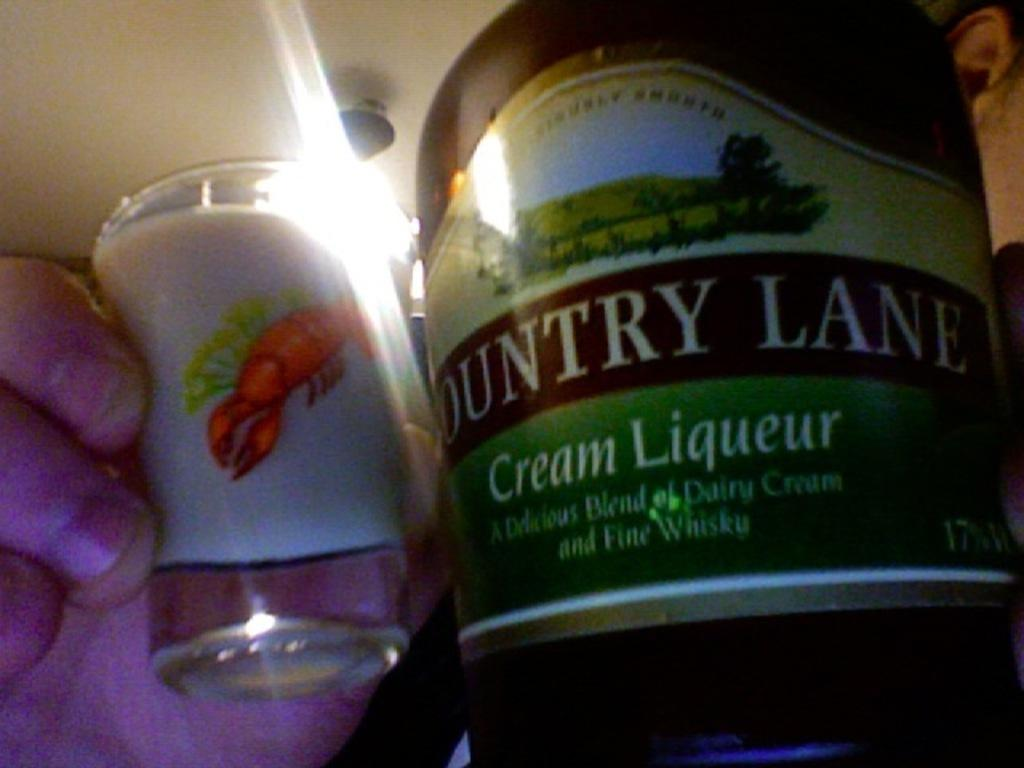<image>
Create a compact narrative representing the image presented. A man holds a shot of liquer with a bottle showing that it is Country Lane. 